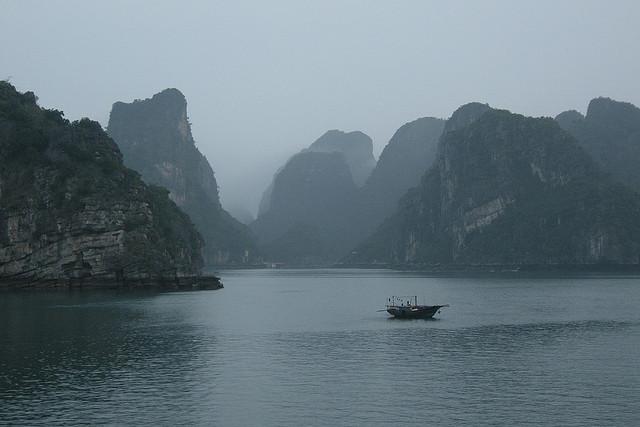Does this picture seem tranquil?
Concise answer only. Yes. What kind of boat is in the water?
Be succinct. Fishing. How many peaks are in the background?
Quick response, please. 8. Does this look like the Grand Canyon?
Concise answer only. No. What is the condition of the water?
Keep it brief. Calm. What kind of boat is this?
Give a very brief answer. Fishing. 